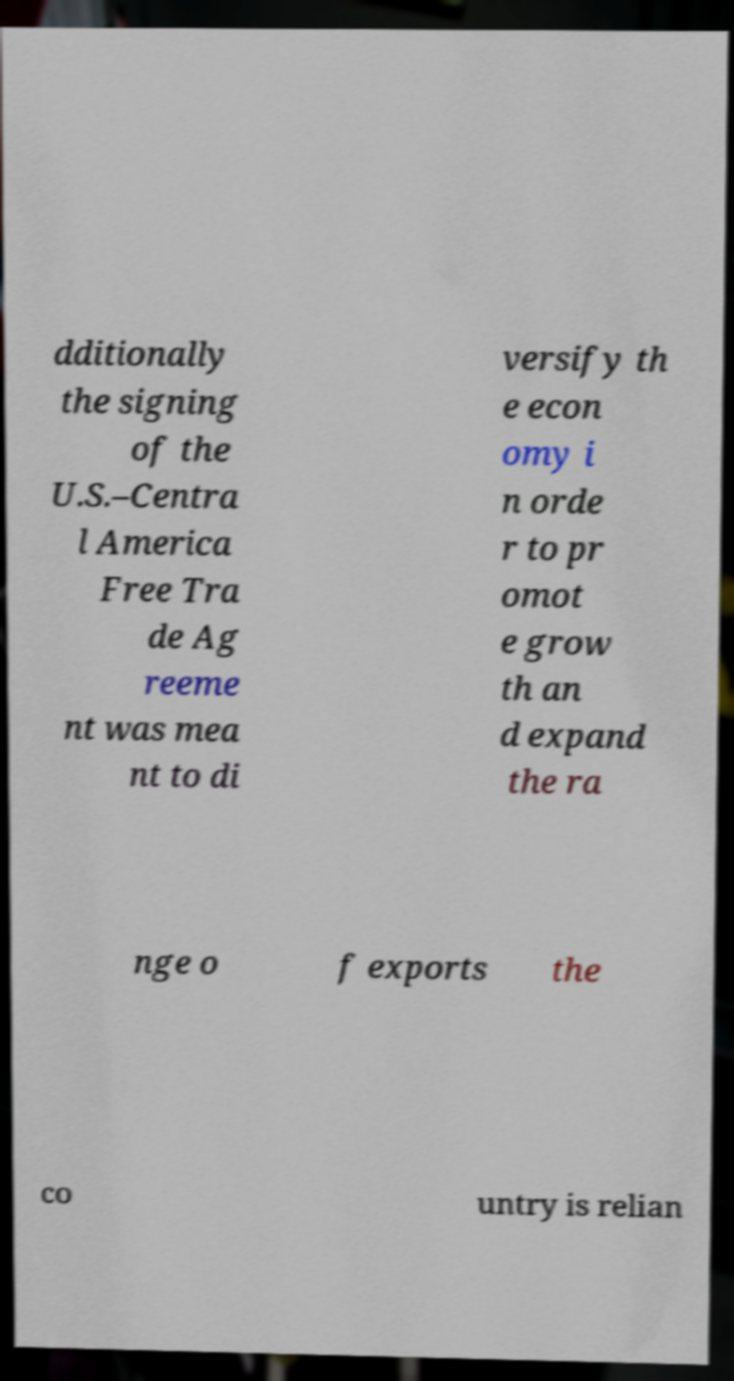Can you read and provide the text displayed in the image?This photo seems to have some interesting text. Can you extract and type it out for me? dditionally the signing of the U.S.–Centra l America Free Tra de Ag reeme nt was mea nt to di versify th e econ omy i n orde r to pr omot e grow th an d expand the ra nge o f exports the co untry is relian 